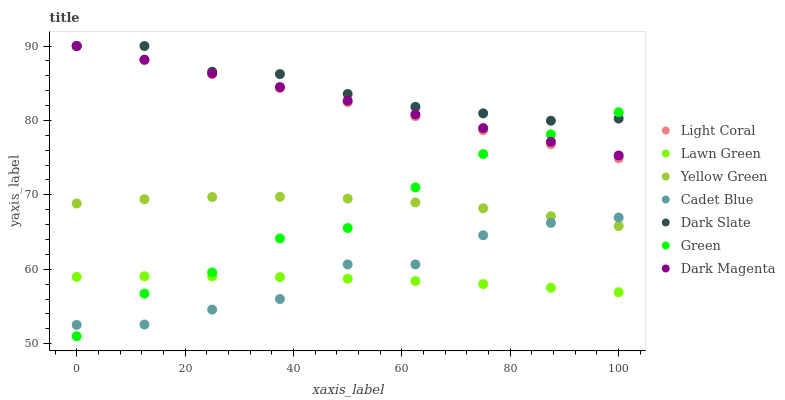Does Lawn Green have the minimum area under the curve?
Answer yes or no. Yes. Does Dark Slate have the maximum area under the curve?
Answer yes or no. Yes. Does Cadet Blue have the minimum area under the curve?
Answer yes or no. No. Does Cadet Blue have the maximum area under the curve?
Answer yes or no. No. Is Dark Magenta the smoothest?
Answer yes or no. Yes. Is Cadet Blue the roughest?
Answer yes or no. Yes. Is Yellow Green the smoothest?
Answer yes or no. No. Is Yellow Green the roughest?
Answer yes or no. No. Does Green have the lowest value?
Answer yes or no. Yes. Does Cadet Blue have the lowest value?
Answer yes or no. No. Does Dark Magenta have the highest value?
Answer yes or no. Yes. Does Cadet Blue have the highest value?
Answer yes or no. No. Is Cadet Blue less than Light Coral?
Answer yes or no. Yes. Is Dark Slate greater than Lawn Green?
Answer yes or no. Yes. Does Dark Magenta intersect Dark Slate?
Answer yes or no. Yes. Is Dark Magenta less than Dark Slate?
Answer yes or no. No. Is Dark Magenta greater than Dark Slate?
Answer yes or no. No. Does Cadet Blue intersect Light Coral?
Answer yes or no. No. 